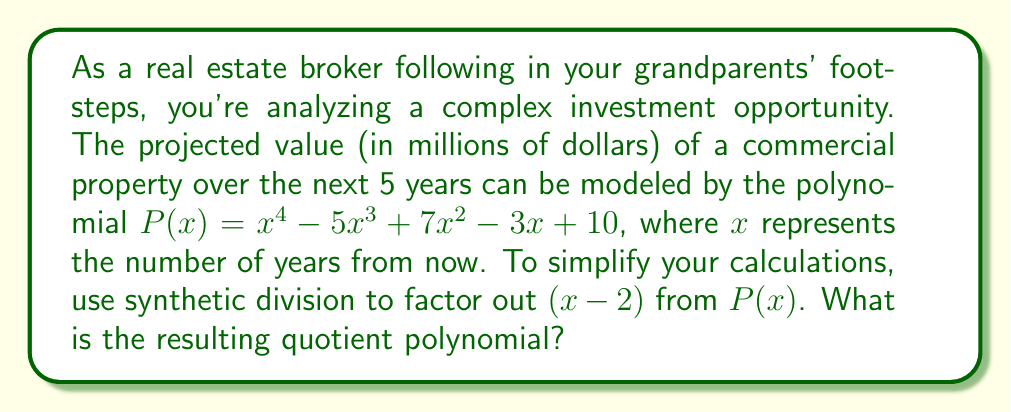Can you solve this math problem? To factor out $(x-2)$ from $P(x)$ using synthetic division, we'll follow these steps:

1) Set up the synthetic division:

   $$\begin{array}{r|rrrr}
   2 & 1 & -5 & 7 & -3 & 10 \\
   \hline
   \end{array}$$

2) Multiply the first term by 2:

   $$\begin{array}{r|rrrr}
   2 & 1 & -5 & 7 & -3 & 10 \\
   & 2 & & & \\
   \hline
   \end{array}$$

3) Add the result to the next term:

   $$\begin{array}{r|rrrr}
   2 & 1 & -3 & 7 & -3 & 10 \\
   & 2 & & & \\
   \hline
   \end{array}$$

4) Repeat steps 2 and 3 for the remaining terms:

   $$\begin{array}{r|rrrr}
   2 & 1 & -3 & 7 & -3 & 10 \\
   & 2 & -2 & 10 & 14 \\
   \hline
   & 1 & -3 & 1 & 7 & 24
   \end{array}$$

5) The bottom row represents the coefficients of the quotient polynomial, which is of degree one less than the original polynomial.

Therefore, the quotient polynomial is:

$Q(x) = x^3 - 3x^2 + x + 7$

This means that $P(x)$ can be factored as:

$P(x) = (x-2)(x^3 - 3x^2 + x + 7) + 24$

The remainder of 24 indicates that $(x-2)$ is not a factor of $P(x)$, but this division still simplifies the polynomial for further analysis.
Answer: $Q(x) = x^3 - 3x^2 + x + 7$ 